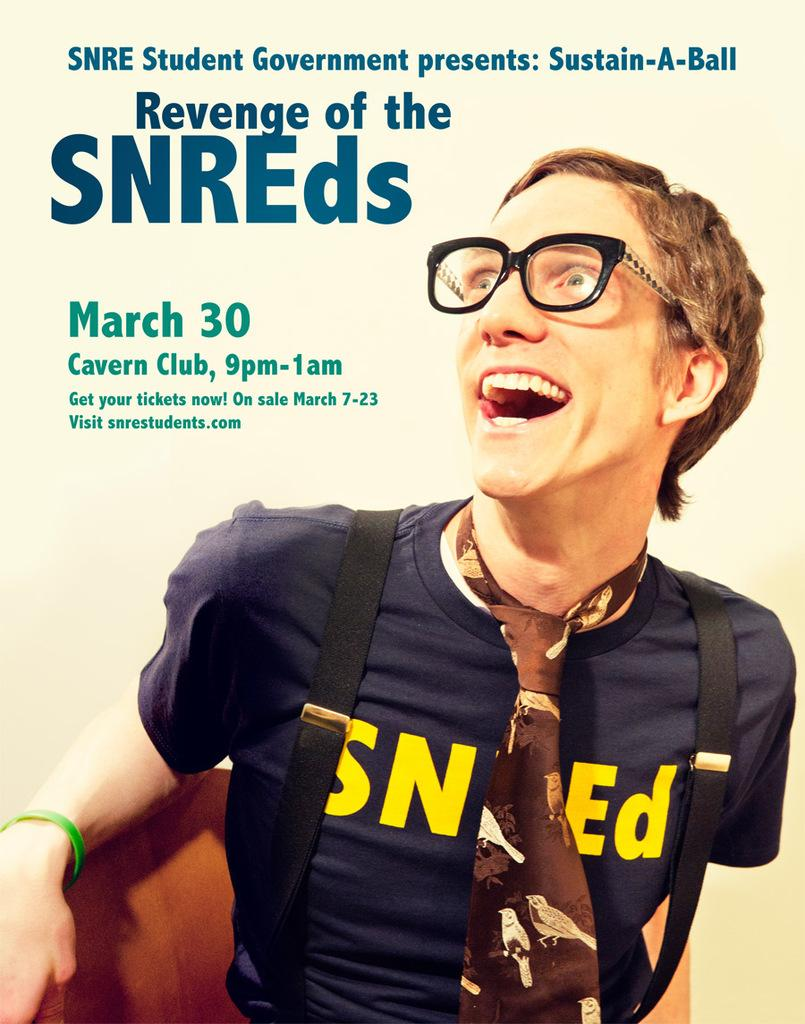What can be seen in the image? There is a person in the image. Can you describe the person's attire? The person is wearing clothes, a tie, and goggles. What is the person carrying in the image? The person is carrying a bag on their back and a handbag. How is the text in the image presented? The text in the image is printed. What grade does the ladybug receive in the image? There is no ladybug present in the image, so it is not possible to determine any grades. 